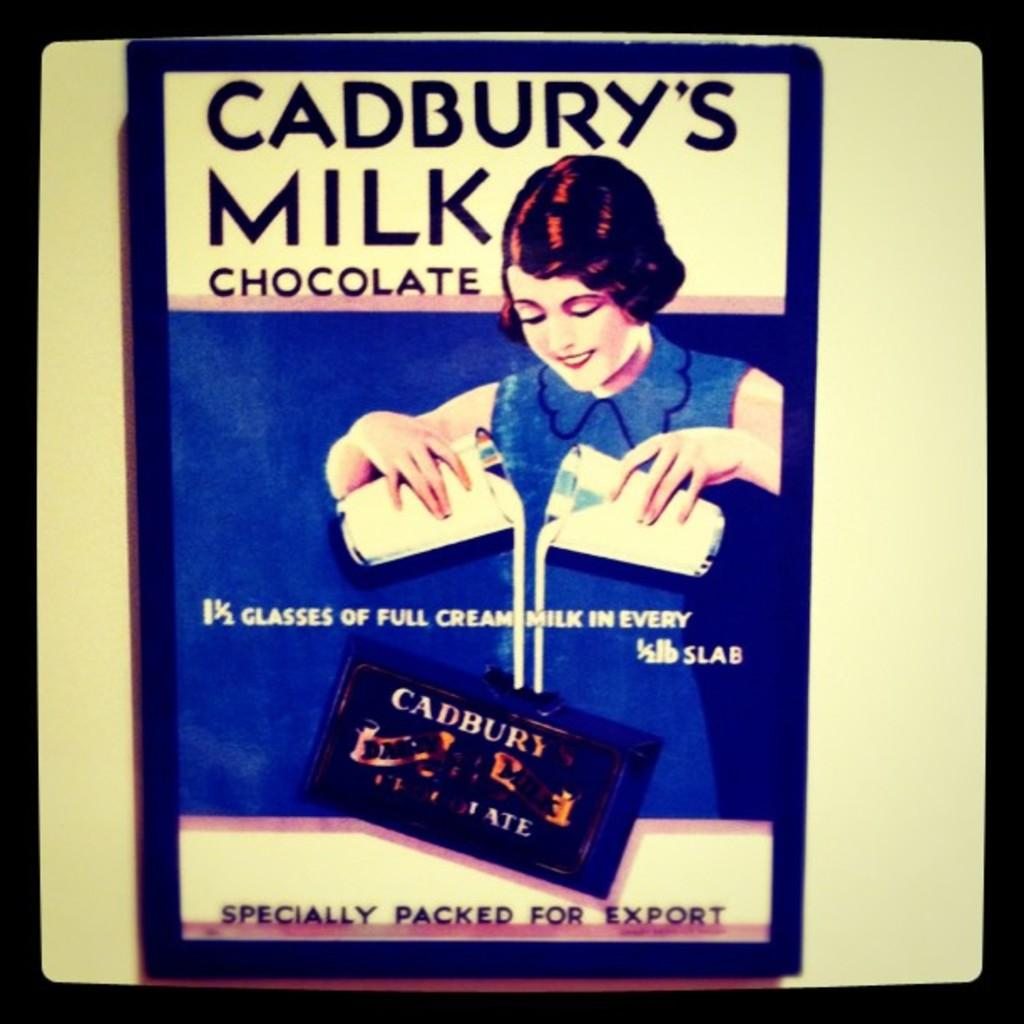<image>
Create a compact narrative representing the image presented. an old fashioned ad for cadbury's milk chocolate 